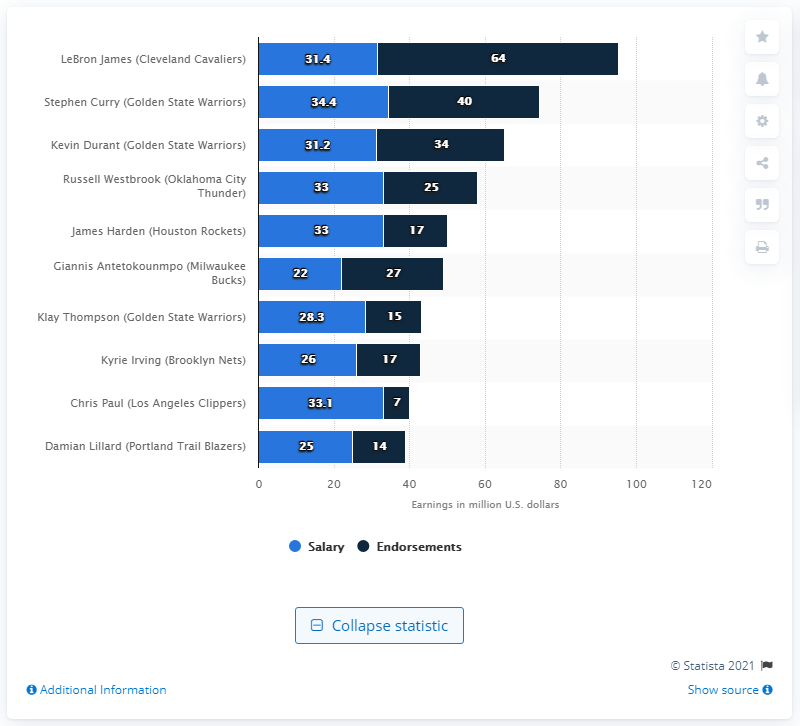Draw attention to some important aspects in this diagram. We have determined the value of the bottom-right bar to be 14.. Chris Paul, a player for the Los Angeles Clippers, has endorsements that are less than half the number of endorsements held by Kyrie Irving. 